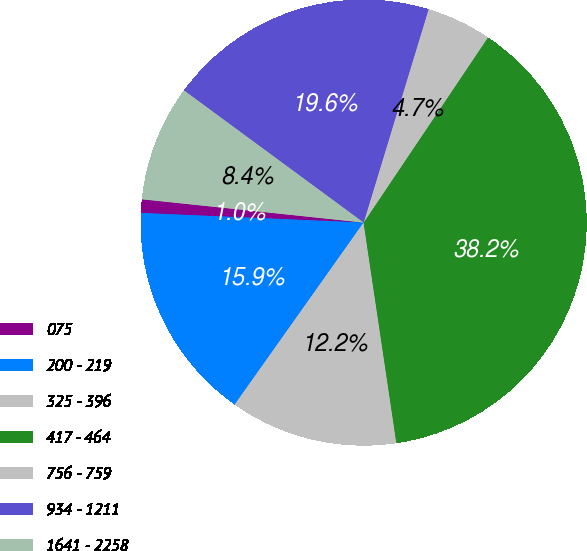Convert chart. <chart><loc_0><loc_0><loc_500><loc_500><pie_chart><fcel>075<fcel>200 - 219<fcel>325 - 396<fcel>417 - 464<fcel>756 - 759<fcel>934 - 1211<fcel>1641 - 2258<nl><fcel>0.98%<fcel>15.88%<fcel>12.16%<fcel>38.24%<fcel>4.71%<fcel>19.61%<fcel>8.43%<nl></chart> 